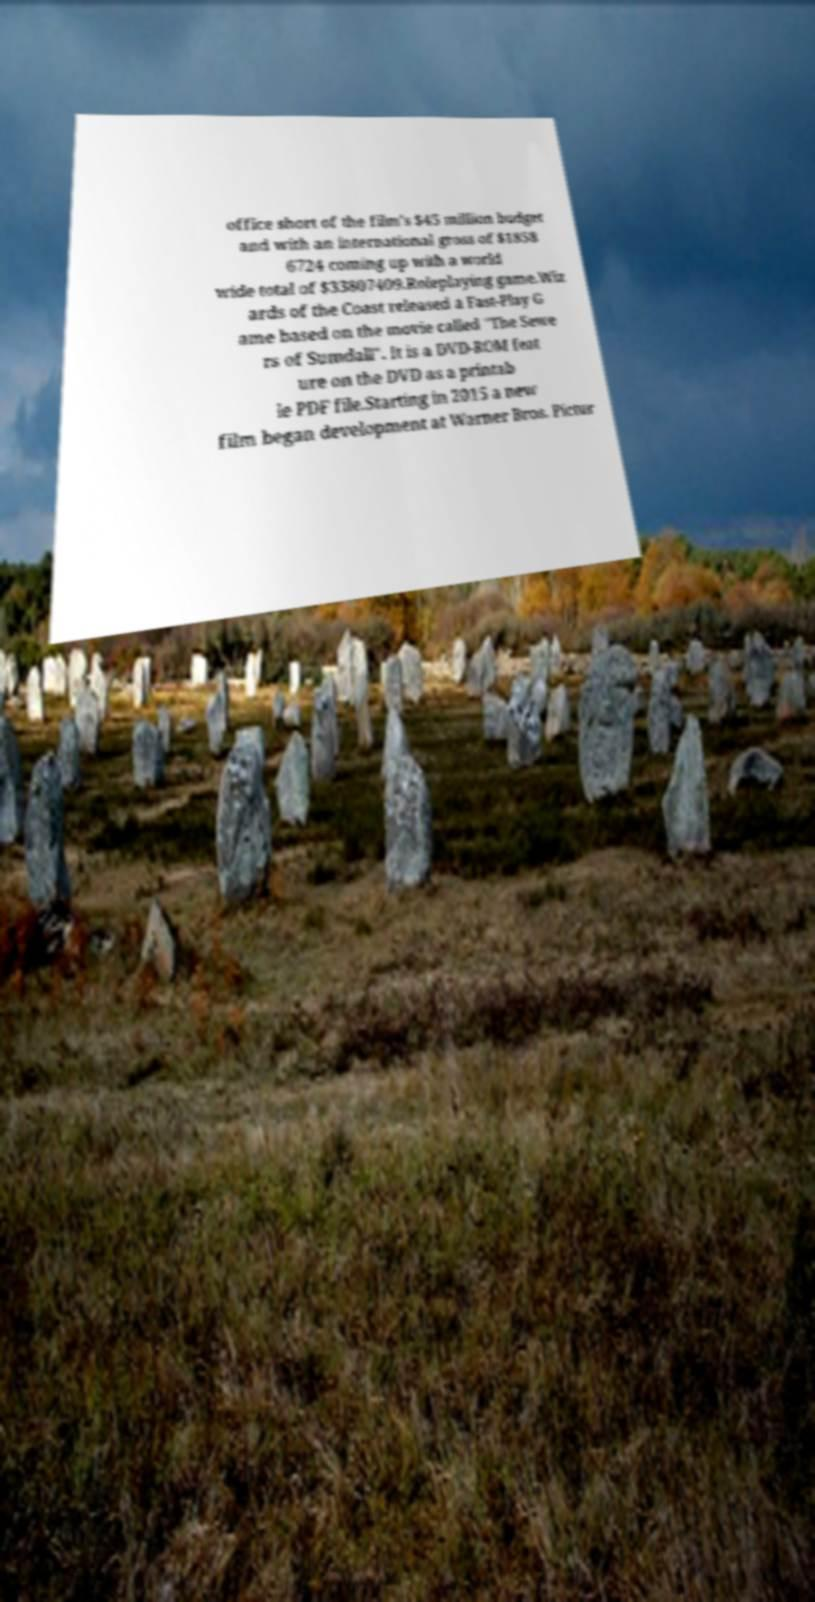Please identify and transcribe the text found in this image. office short of the film's $45 million budget and with an international gross of $1858 6724 coming up with a world wide total of $33807409.Roleplaying game.Wiz ards of the Coast released a Fast-Play G ame based on the movie called "The Sewe rs of Sumdall". It is a DVD-ROM feat ure on the DVD as a printab le PDF file.Starting in 2015 a new film began development at Warner Bros. Pictur 